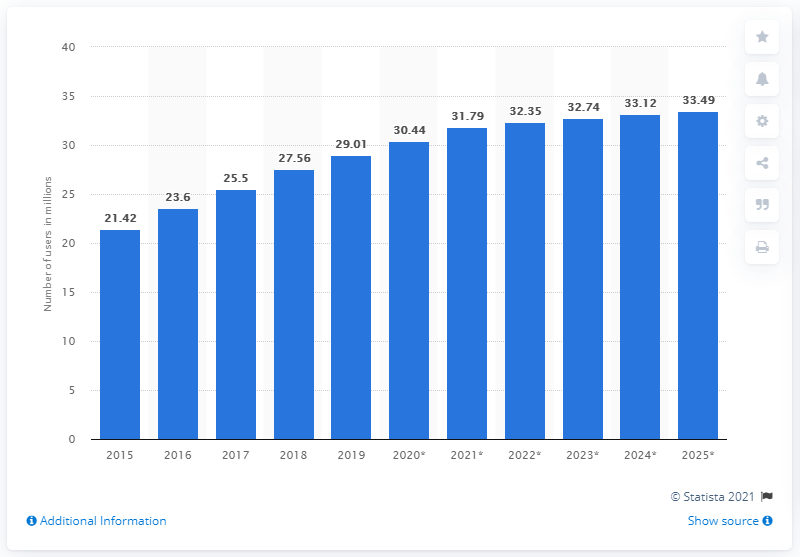Identify some key points in this picture. According to projections, it is expected that there will be approximately 33.49 million internet users in Malaysia by 2025. In 2019, the number of people accessing the internet in Malaysia was approximately 29.01 million. 